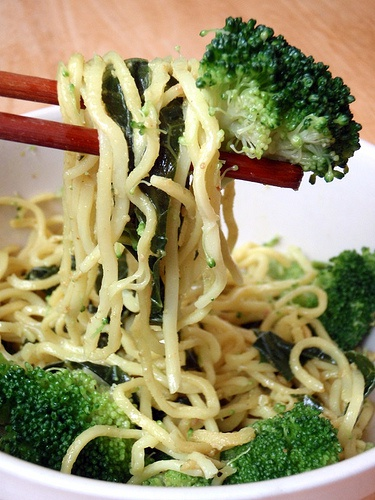Describe the objects in this image and their specific colors. I can see bowl in tan, white, darkgray, and khaki tones, broccoli in tan, black, darkgreen, and olive tones, broccoli in tan, black, darkgreen, and olive tones, broccoli in tan, darkgreen, and green tones, and broccoli in tan, black, darkgreen, and lightgray tones in this image. 